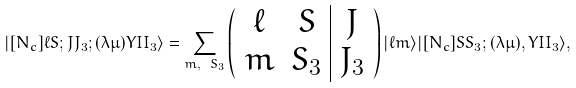<formula> <loc_0><loc_0><loc_500><loc_500>| [ N _ { c } ] \ell S ; J J _ { 3 } ; ( \lambda \mu ) Y I I _ { 3 } \rangle = \sum _ { m , \ S _ { 3 } } \left ( \begin{array} { c c | c } \ell & S & J \\ m & S _ { 3 } & J _ { 3 } \end{array} \right ) | \ell m \rangle | [ N _ { c } ] S S _ { 3 } ; ( \lambda \mu ) , Y I I _ { 3 } \rangle ,</formula> 